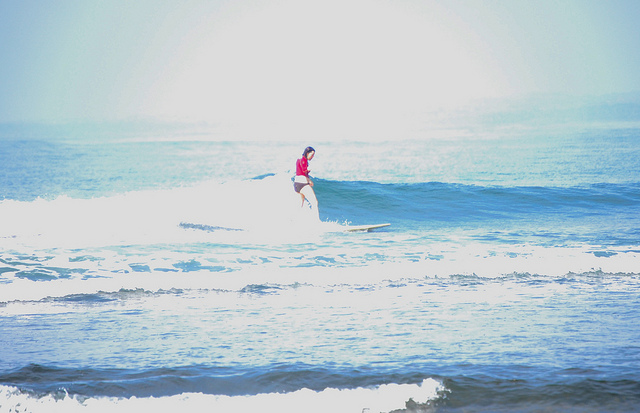<image>Is the image blown out? It is ambiguous whether the image is blown out or not. Is the image blown out? I am not sure if the image is blown out. It can be both blown out and not blown out. 